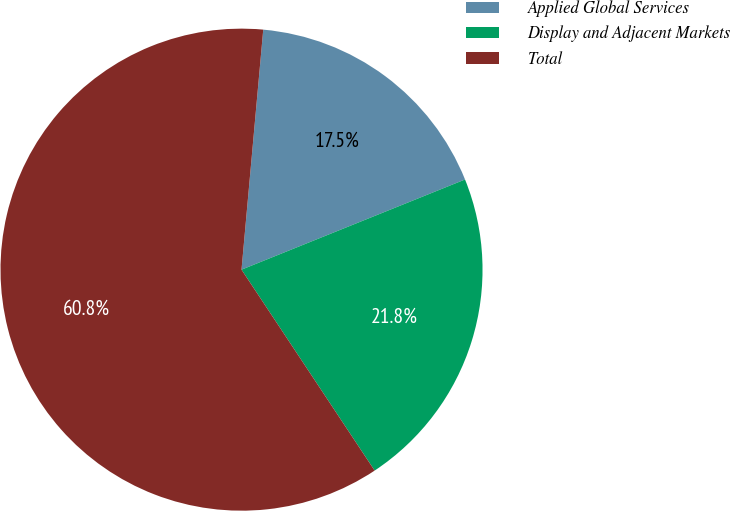Convert chart. <chart><loc_0><loc_0><loc_500><loc_500><pie_chart><fcel>Applied Global Services<fcel>Display and Adjacent Markets<fcel>Total<nl><fcel>17.46%<fcel>21.79%<fcel>60.75%<nl></chart> 